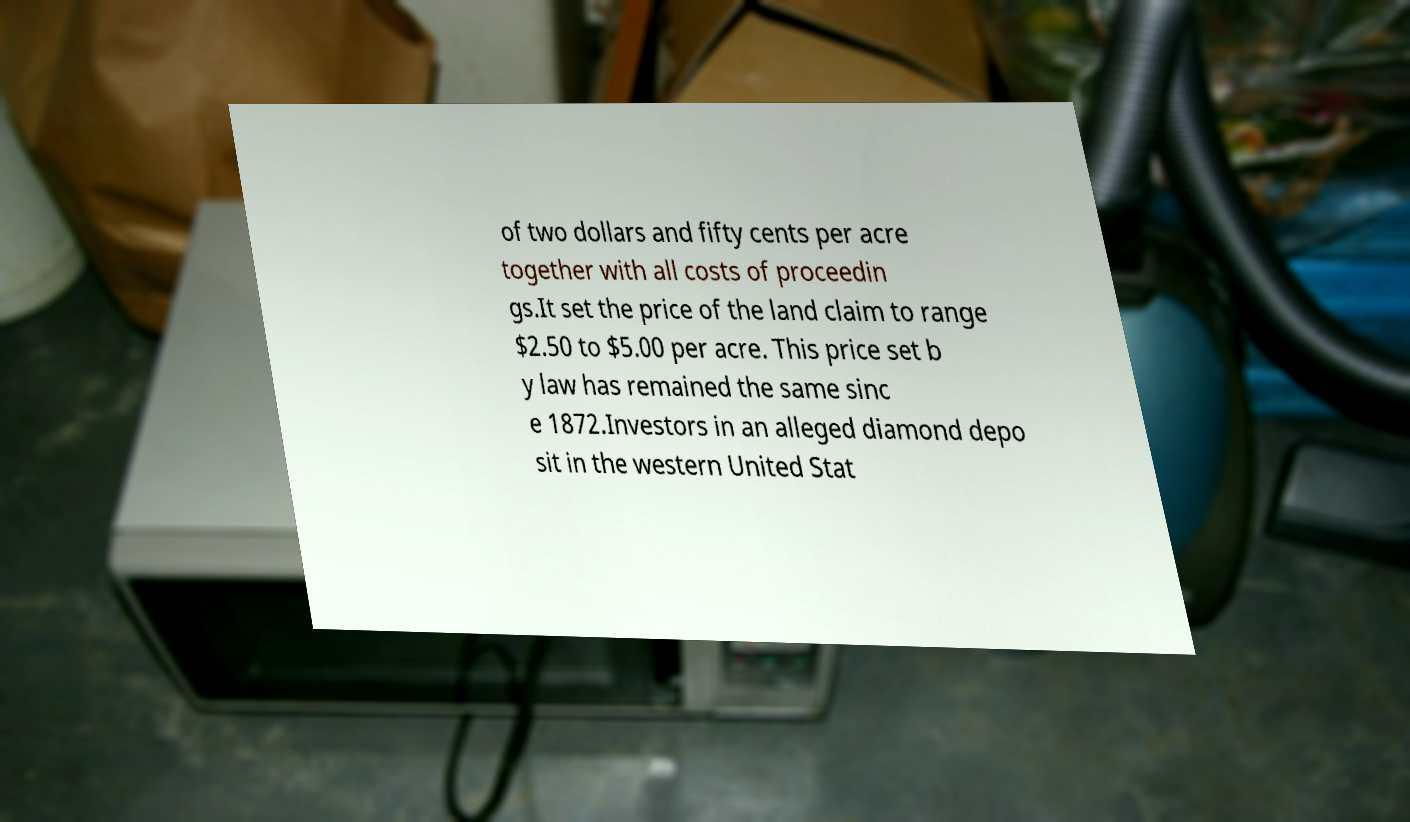Could you assist in decoding the text presented in this image and type it out clearly? of two dollars and fifty cents per acre together with all costs of proceedin gs.It set the price of the land claim to range $2.50 to $5.00 per acre. This price set b y law has remained the same sinc e 1872.Investors in an alleged diamond depo sit in the western United Stat 